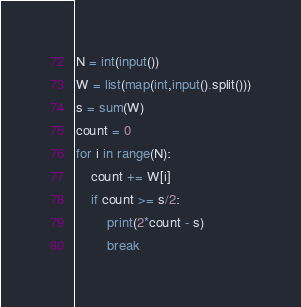<code> <loc_0><loc_0><loc_500><loc_500><_Python_>N = int(input())
W = list(map(int,input().split()))
s = sum(W)
count = 0
for i in range(N):
    count += W[i]
    if count >= s/2:
        print(2*count - s)
        break
</code> 